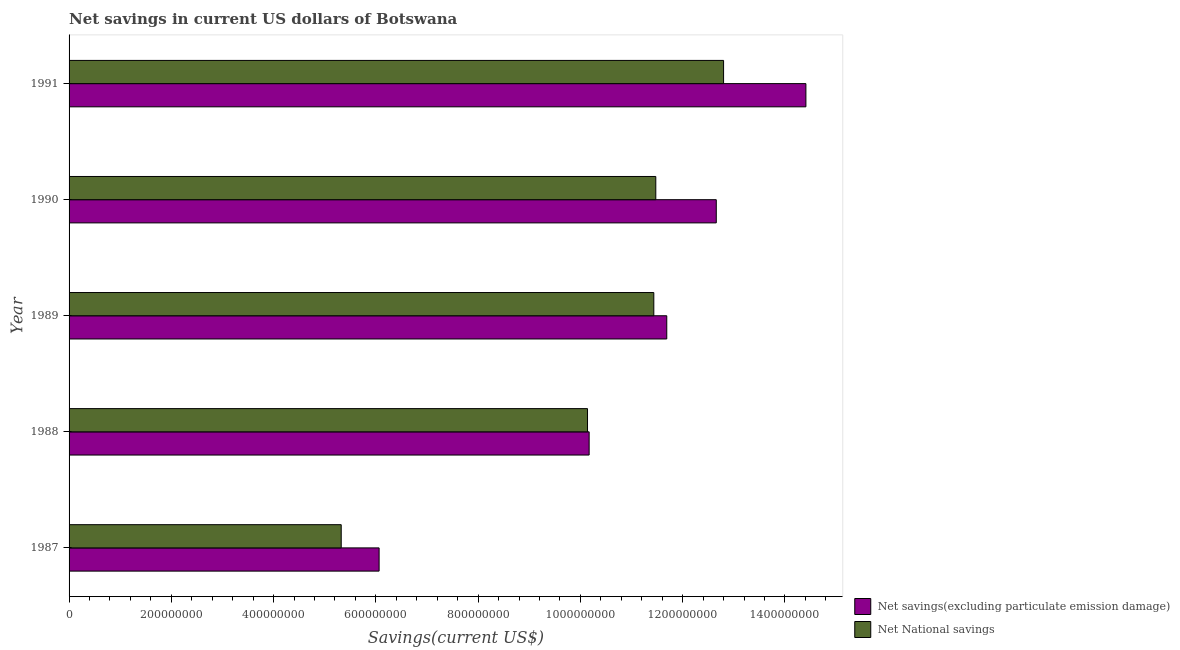How many different coloured bars are there?
Your answer should be compact. 2. How many groups of bars are there?
Your answer should be very brief. 5. Are the number of bars per tick equal to the number of legend labels?
Keep it short and to the point. Yes. Are the number of bars on each tick of the Y-axis equal?
Your response must be concise. Yes. How many bars are there on the 2nd tick from the top?
Keep it short and to the point. 2. What is the label of the 3rd group of bars from the top?
Provide a short and direct response. 1989. What is the net national savings in 1991?
Provide a succinct answer. 1.28e+09. Across all years, what is the maximum net savings(excluding particulate emission damage)?
Your answer should be very brief. 1.44e+09. Across all years, what is the minimum net savings(excluding particulate emission damage)?
Give a very brief answer. 6.06e+08. In which year was the net savings(excluding particulate emission damage) minimum?
Your answer should be compact. 1987. What is the total net savings(excluding particulate emission damage) in the graph?
Provide a short and direct response. 5.50e+09. What is the difference between the net national savings in 1987 and that in 1989?
Your response must be concise. -6.11e+08. What is the difference between the net national savings in 1990 and the net savings(excluding particulate emission damage) in 1991?
Offer a very short reply. -2.94e+08. What is the average net savings(excluding particulate emission damage) per year?
Your answer should be compact. 1.10e+09. In the year 1990, what is the difference between the net national savings and net savings(excluding particulate emission damage)?
Provide a short and direct response. -1.18e+08. In how many years, is the net national savings greater than 1080000000 US$?
Ensure brevity in your answer.  3. What is the ratio of the net savings(excluding particulate emission damage) in 1989 to that in 1990?
Offer a very short reply. 0.92. Is the difference between the net savings(excluding particulate emission damage) in 1987 and 1991 greater than the difference between the net national savings in 1987 and 1991?
Your response must be concise. No. What is the difference between the highest and the second highest net savings(excluding particulate emission damage)?
Offer a terse response. 1.75e+08. What is the difference between the highest and the lowest net national savings?
Provide a short and direct response. 7.48e+08. In how many years, is the net savings(excluding particulate emission damage) greater than the average net savings(excluding particulate emission damage) taken over all years?
Your answer should be very brief. 3. Is the sum of the net savings(excluding particulate emission damage) in 1987 and 1988 greater than the maximum net national savings across all years?
Make the answer very short. Yes. What does the 2nd bar from the top in 1991 represents?
Ensure brevity in your answer.  Net savings(excluding particulate emission damage). What does the 2nd bar from the bottom in 1989 represents?
Your answer should be very brief. Net National savings. Are all the bars in the graph horizontal?
Provide a succinct answer. Yes. How many years are there in the graph?
Offer a terse response. 5. Are the values on the major ticks of X-axis written in scientific E-notation?
Ensure brevity in your answer.  No. Does the graph contain grids?
Your answer should be compact. No. How are the legend labels stacked?
Provide a succinct answer. Vertical. What is the title of the graph?
Your answer should be very brief. Net savings in current US dollars of Botswana. What is the label or title of the X-axis?
Offer a terse response. Savings(current US$). What is the label or title of the Y-axis?
Keep it short and to the point. Year. What is the Savings(current US$) in Net savings(excluding particulate emission damage) in 1987?
Your answer should be very brief. 6.06e+08. What is the Savings(current US$) of Net National savings in 1987?
Offer a very short reply. 5.32e+08. What is the Savings(current US$) of Net savings(excluding particulate emission damage) in 1988?
Keep it short and to the point. 1.02e+09. What is the Savings(current US$) in Net National savings in 1988?
Offer a very short reply. 1.01e+09. What is the Savings(current US$) in Net savings(excluding particulate emission damage) in 1989?
Offer a very short reply. 1.17e+09. What is the Savings(current US$) of Net National savings in 1989?
Give a very brief answer. 1.14e+09. What is the Savings(current US$) in Net savings(excluding particulate emission damage) in 1990?
Provide a short and direct response. 1.27e+09. What is the Savings(current US$) in Net National savings in 1990?
Provide a succinct answer. 1.15e+09. What is the Savings(current US$) of Net savings(excluding particulate emission damage) in 1991?
Give a very brief answer. 1.44e+09. What is the Savings(current US$) of Net National savings in 1991?
Keep it short and to the point. 1.28e+09. Across all years, what is the maximum Savings(current US$) in Net savings(excluding particulate emission damage)?
Offer a very short reply. 1.44e+09. Across all years, what is the maximum Savings(current US$) of Net National savings?
Offer a very short reply. 1.28e+09. Across all years, what is the minimum Savings(current US$) in Net savings(excluding particulate emission damage)?
Provide a succinct answer. 6.06e+08. Across all years, what is the minimum Savings(current US$) of Net National savings?
Your response must be concise. 5.32e+08. What is the total Savings(current US$) of Net savings(excluding particulate emission damage) in the graph?
Ensure brevity in your answer.  5.50e+09. What is the total Savings(current US$) in Net National savings in the graph?
Your response must be concise. 5.12e+09. What is the difference between the Savings(current US$) of Net savings(excluding particulate emission damage) in 1987 and that in 1988?
Offer a very short reply. -4.11e+08. What is the difference between the Savings(current US$) of Net National savings in 1987 and that in 1988?
Make the answer very short. -4.82e+08. What is the difference between the Savings(current US$) of Net savings(excluding particulate emission damage) in 1987 and that in 1989?
Provide a succinct answer. -5.63e+08. What is the difference between the Savings(current US$) of Net National savings in 1987 and that in 1989?
Your answer should be compact. -6.11e+08. What is the difference between the Savings(current US$) in Net savings(excluding particulate emission damage) in 1987 and that in 1990?
Offer a terse response. -6.59e+08. What is the difference between the Savings(current US$) in Net National savings in 1987 and that in 1990?
Provide a short and direct response. -6.15e+08. What is the difference between the Savings(current US$) in Net savings(excluding particulate emission damage) in 1987 and that in 1991?
Make the answer very short. -8.35e+08. What is the difference between the Savings(current US$) in Net National savings in 1987 and that in 1991?
Provide a succinct answer. -7.48e+08. What is the difference between the Savings(current US$) of Net savings(excluding particulate emission damage) in 1988 and that in 1989?
Your answer should be very brief. -1.52e+08. What is the difference between the Savings(current US$) in Net National savings in 1988 and that in 1989?
Give a very brief answer. -1.30e+08. What is the difference between the Savings(current US$) of Net savings(excluding particulate emission damage) in 1988 and that in 1990?
Your answer should be compact. -2.49e+08. What is the difference between the Savings(current US$) in Net National savings in 1988 and that in 1990?
Provide a succinct answer. -1.34e+08. What is the difference between the Savings(current US$) of Net savings(excluding particulate emission damage) in 1988 and that in 1991?
Ensure brevity in your answer.  -4.24e+08. What is the difference between the Savings(current US$) of Net National savings in 1988 and that in 1991?
Offer a very short reply. -2.66e+08. What is the difference between the Savings(current US$) in Net savings(excluding particulate emission damage) in 1989 and that in 1990?
Offer a terse response. -9.68e+07. What is the difference between the Savings(current US$) of Net National savings in 1989 and that in 1990?
Ensure brevity in your answer.  -3.87e+06. What is the difference between the Savings(current US$) of Net savings(excluding particulate emission damage) in 1989 and that in 1991?
Your response must be concise. -2.72e+08. What is the difference between the Savings(current US$) of Net National savings in 1989 and that in 1991?
Give a very brief answer. -1.36e+08. What is the difference between the Savings(current US$) of Net savings(excluding particulate emission damage) in 1990 and that in 1991?
Keep it short and to the point. -1.75e+08. What is the difference between the Savings(current US$) of Net National savings in 1990 and that in 1991?
Provide a short and direct response. -1.33e+08. What is the difference between the Savings(current US$) in Net savings(excluding particulate emission damage) in 1987 and the Savings(current US$) in Net National savings in 1988?
Offer a terse response. -4.08e+08. What is the difference between the Savings(current US$) of Net savings(excluding particulate emission damage) in 1987 and the Savings(current US$) of Net National savings in 1989?
Offer a very short reply. -5.37e+08. What is the difference between the Savings(current US$) in Net savings(excluding particulate emission damage) in 1987 and the Savings(current US$) in Net National savings in 1990?
Your response must be concise. -5.41e+08. What is the difference between the Savings(current US$) of Net savings(excluding particulate emission damage) in 1987 and the Savings(current US$) of Net National savings in 1991?
Provide a succinct answer. -6.74e+08. What is the difference between the Savings(current US$) of Net savings(excluding particulate emission damage) in 1988 and the Savings(current US$) of Net National savings in 1989?
Give a very brief answer. -1.26e+08. What is the difference between the Savings(current US$) of Net savings(excluding particulate emission damage) in 1988 and the Savings(current US$) of Net National savings in 1990?
Offer a very short reply. -1.30e+08. What is the difference between the Savings(current US$) in Net savings(excluding particulate emission damage) in 1988 and the Savings(current US$) in Net National savings in 1991?
Offer a terse response. -2.63e+08. What is the difference between the Savings(current US$) in Net savings(excluding particulate emission damage) in 1989 and the Savings(current US$) in Net National savings in 1990?
Your answer should be very brief. 2.14e+07. What is the difference between the Savings(current US$) of Net savings(excluding particulate emission damage) in 1989 and the Savings(current US$) of Net National savings in 1991?
Offer a terse response. -1.11e+08. What is the difference between the Savings(current US$) of Net savings(excluding particulate emission damage) in 1990 and the Savings(current US$) of Net National savings in 1991?
Keep it short and to the point. -1.43e+07. What is the average Savings(current US$) in Net savings(excluding particulate emission damage) per year?
Make the answer very short. 1.10e+09. What is the average Savings(current US$) in Net National savings per year?
Keep it short and to the point. 1.02e+09. In the year 1987, what is the difference between the Savings(current US$) in Net savings(excluding particulate emission damage) and Savings(current US$) in Net National savings?
Your response must be concise. 7.41e+07. In the year 1988, what is the difference between the Savings(current US$) in Net savings(excluding particulate emission damage) and Savings(current US$) in Net National savings?
Give a very brief answer. 3.18e+06. In the year 1989, what is the difference between the Savings(current US$) of Net savings(excluding particulate emission damage) and Savings(current US$) of Net National savings?
Your response must be concise. 2.53e+07. In the year 1990, what is the difference between the Savings(current US$) of Net savings(excluding particulate emission damage) and Savings(current US$) of Net National savings?
Give a very brief answer. 1.18e+08. In the year 1991, what is the difference between the Savings(current US$) of Net savings(excluding particulate emission damage) and Savings(current US$) of Net National savings?
Your answer should be very brief. 1.61e+08. What is the ratio of the Savings(current US$) in Net savings(excluding particulate emission damage) in 1987 to that in 1988?
Keep it short and to the point. 0.6. What is the ratio of the Savings(current US$) of Net National savings in 1987 to that in 1988?
Offer a terse response. 0.52. What is the ratio of the Savings(current US$) of Net savings(excluding particulate emission damage) in 1987 to that in 1989?
Offer a very short reply. 0.52. What is the ratio of the Savings(current US$) of Net National savings in 1987 to that in 1989?
Your answer should be compact. 0.47. What is the ratio of the Savings(current US$) in Net savings(excluding particulate emission damage) in 1987 to that in 1990?
Offer a terse response. 0.48. What is the ratio of the Savings(current US$) in Net National savings in 1987 to that in 1990?
Ensure brevity in your answer.  0.46. What is the ratio of the Savings(current US$) of Net savings(excluding particulate emission damage) in 1987 to that in 1991?
Offer a very short reply. 0.42. What is the ratio of the Savings(current US$) in Net National savings in 1987 to that in 1991?
Make the answer very short. 0.42. What is the ratio of the Savings(current US$) in Net savings(excluding particulate emission damage) in 1988 to that in 1989?
Your answer should be very brief. 0.87. What is the ratio of the Savings(current US$) in Net National savings in 1988 to that in 1989?
Make the answer very short. 0.89. What is the ratio of the Savings(current US$) in Net savings(excluding particulate emission damage) in 1988 to that in 1990?
Provide a succinct answer. 0.8. What is the ratio of the Savings(current US$) of Net National savings in 1988 to that in 1990?
Offer a very short reply. 0.88. What is the ratio of the Savings(current US$) in Net savings(excluding particulate emission damage) in 1988 to that in 1991?
Keep it short and to the point. 0.71. What is the ratio of the Savings(current US$) of Net National savings in 1988 to that in 1991?
Your response must be concise. 0.79. What is the ratio of the Savings(current US$) of Net savings(excluding particulate emission damage) in 1989 to that in 1990?
Give a very brief answer. 0.92. What is the ratio of the Savings(current US$) in Net savings(excluding particulate emission damage) in 1989 to that in 1991?
Your answer should be very brief. 0.81. What is the ratio of the Savings(current US$) of Net National savings in 1989 to that in 1991?
Keep it short and to the point. 0.89. What is the ratio of the Savings(current US$) in Net savings(excluding particulate emission damage) in 1990 to that in 1991?
Give a very brief answer. 0.88. What is the ratio of the Savings(current US$) in Net National savings in 1990 to that in 1991?
Offer a very short reply. 0.9. What is the difference between the highest and the second highest Savings(current US$) in Net savings(excluding particulate emission damage)?
Your answer should be very brief. 1.75e+08. What is the difference between the highest and the second highest Savings(current US$) in Net National savings?
Offer a terse response. 1.33e+08. What is the difference between the highest and the lowest Savings(current US$) in Net savings(excluding particulate emission damage)?
Provide a short and direct response. 8.35e+08. What is the difference between the highest and the lowest Savings(current US$) in Net National savings?
Make the answer very short. 7.48e+08. 